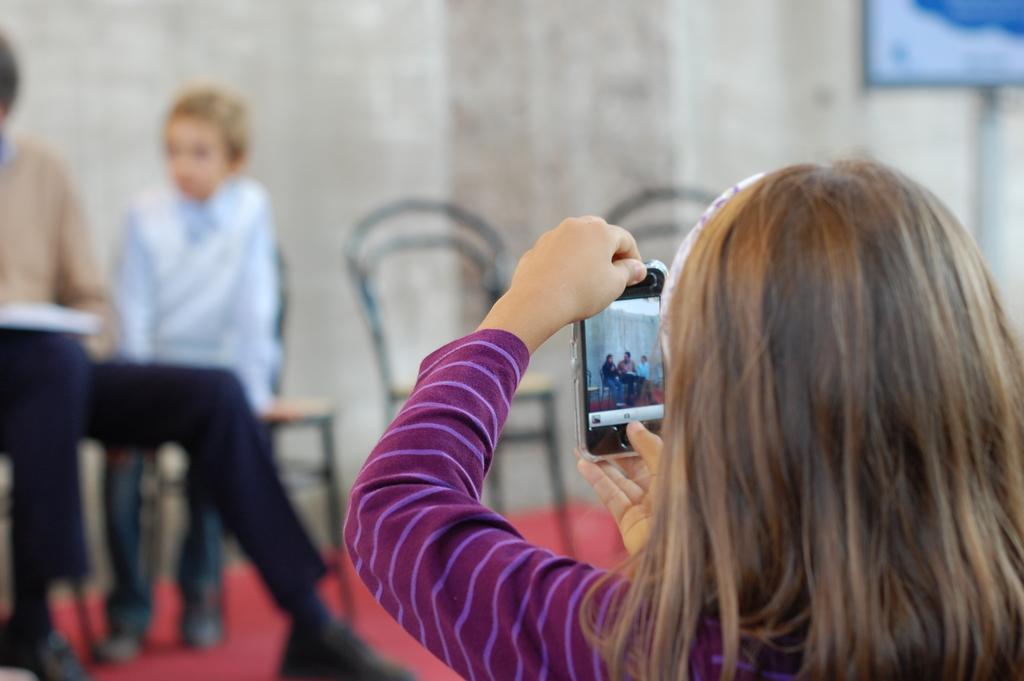Can you describe this image briefly? In this image we can see a girl holding a mobile phone and taking the picture of the two persons sitting in front of her and in the background we can see the chairs. 